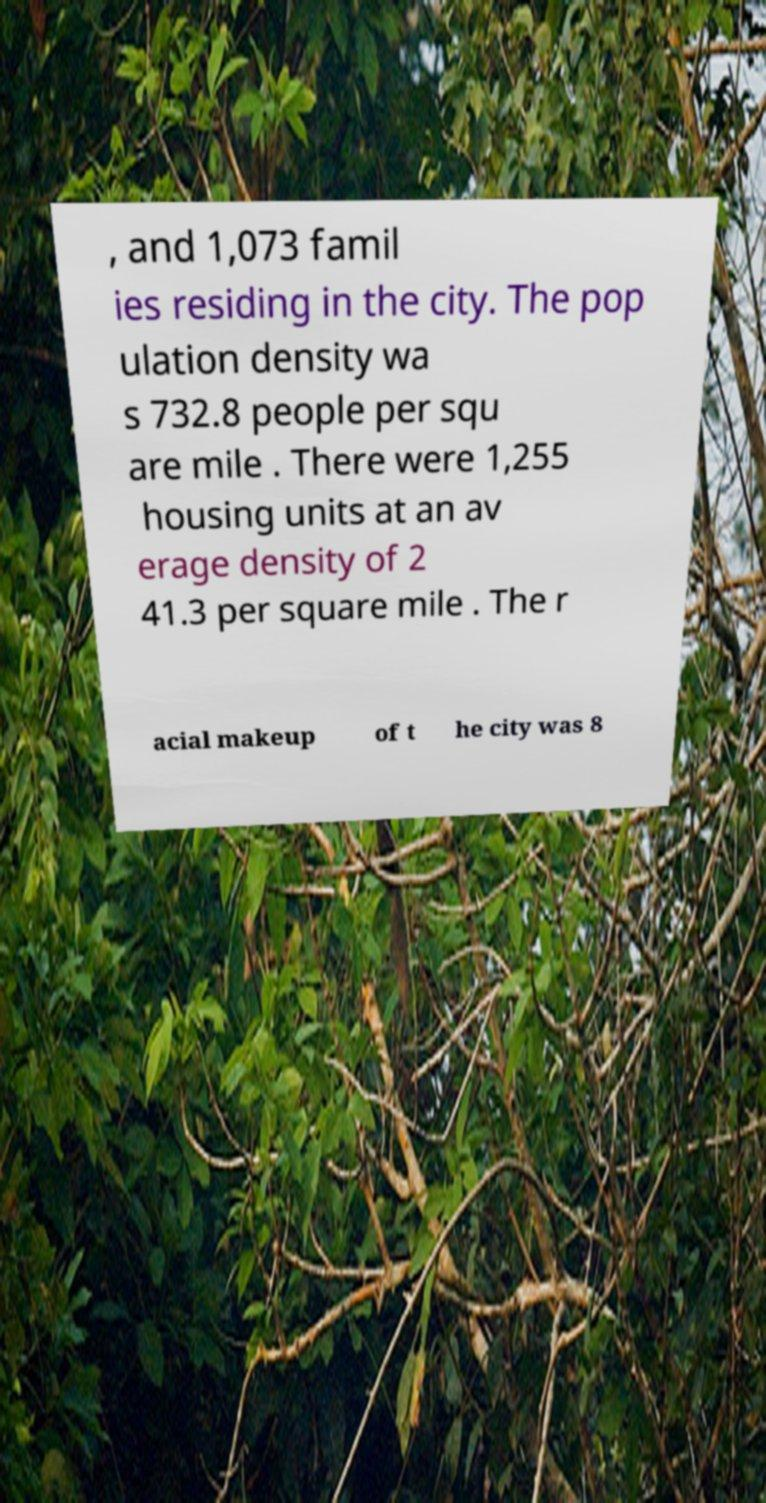Please identify and transcribe the text found in this image. , and 1,073 famil ies residing in the city. The pop ulation density wa s 732.8 people per squ are mile . There were 1,255 housing units at an av erage density of 2 41.3 per square mile . The r acial makeup of t he city was 8 